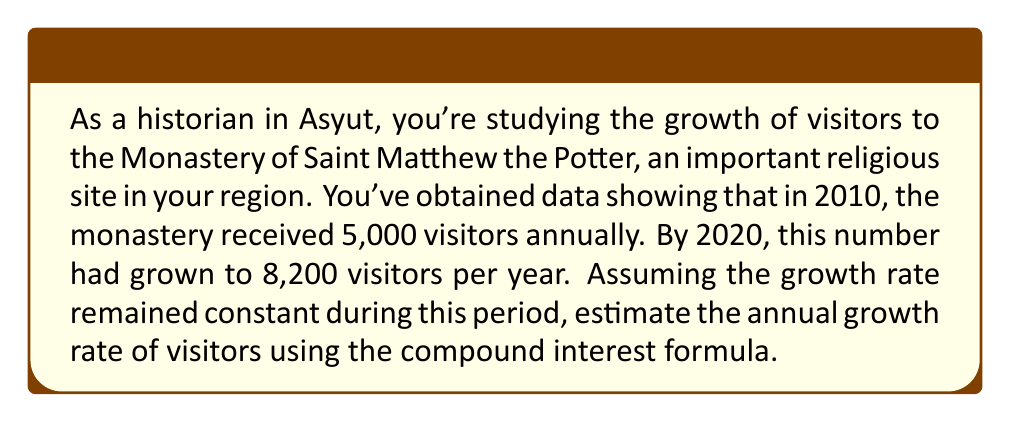Help me with this question. To solve this problem, we'll use the compound interest formula:

$$A = P(1 + r)^t$$

Where:
$A$ = Final amount (8,200 visitors in 2020)
$P$ = Initial amount (5,000 visitors in 2010)
$r$ = Annual growth rate (what we're solving for)
$t$ = Time period (10 years, from 2010 to 2020)

Let's substitute these values into the formula:

$$8200 = 5000(1 + r)^{10}$$

Now, we'll solve for $r$:

1) Divide both sides by 5000:
   $$\frac{8200}{5000} = (1 + r)^{10}$$

2) Take the 10th root of both sides:
   $$\sqrt[10]{\frac{8200}{5000}} = 1 + r$$

3) Subtract 1 from both sides:
   $$\sqrt[10]{\frac{8200}{5000}} - 1 = r$$

4) Calculate the value:
   $$r = \sqrt[10]{1.64} - 1 = 1.0507 - 1 = 0.0507$$

5) Convert to a percentage:
   $$r = 0.0507 \times 100\% = 5.07\%$$

Therefore, the estimated annual growth rate of visitors to the Monastery of Saint Matthew the Potter is approximately 5.07%.
Answer: The estimated annual growth rate of visitors is 5.07%. 